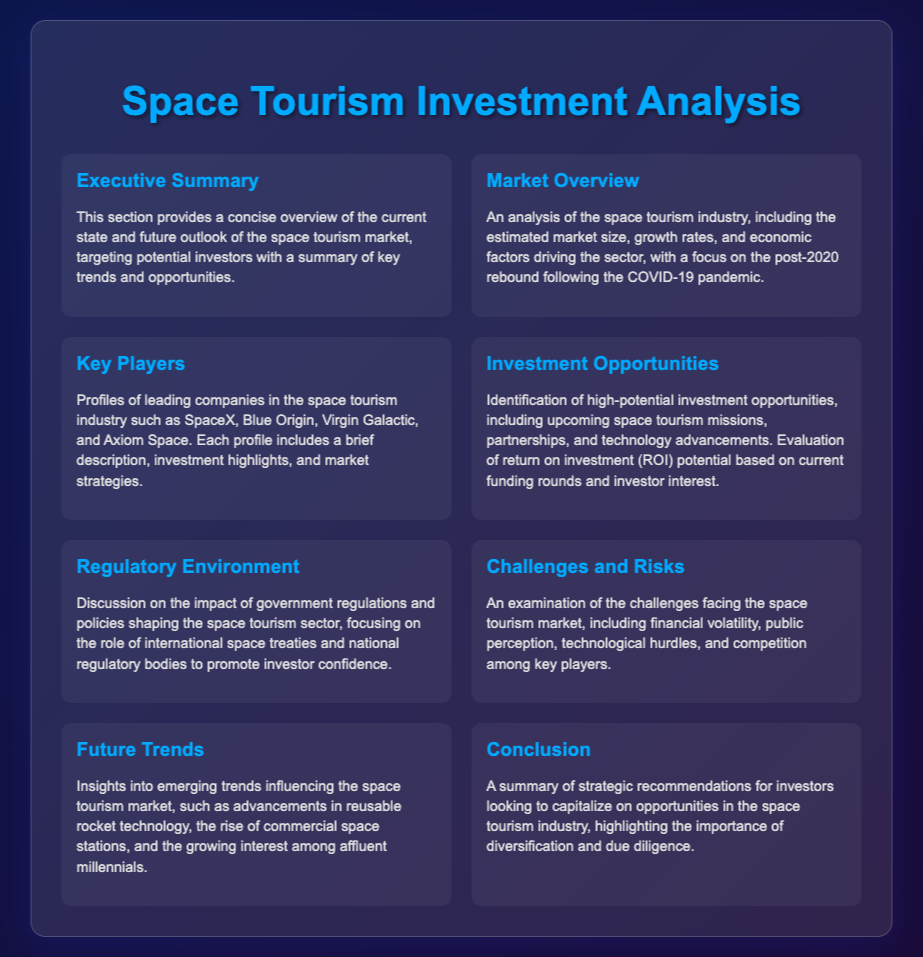What is the focus of the Executive Summary? The Executive Summary provides a concise overview of the current state and future outlook of the space tourism market.
Answer: Overview of the current state and future outlook What companies are highlighted in the Key Players section? The Key Players section profiles leading companies such as SpaceX, Blue Origin, Virgin Galactic, and Axiom Space.
Answer: SpaceX, Blue Origin, Virgin Galactic, Axiom Space What does the Investment Opportunities section identify? The Investment Opportunities section identifies high-potential investment opportunities, including upcoming missions and partnerships.
Answer: High-potential investment opportunities What major factor does the Regulatory Environment discuss? The Regulatory Environment discusses the impact of government regulations and policies on the space tourism sector.
Answer: Government regulations and policies What are some challenges mentioned in the Challenges and Risks section? The Challenges and Risks section examines challenges such as financial volatility, public perception, and competition.
Answer: Financial volatility, public perception, competition What is a trend mentioned in the Future Trends section? The Future Trends section offers insights into advancements in reusable rocket technology.
Answer: Advancements in reusable rocket technology 